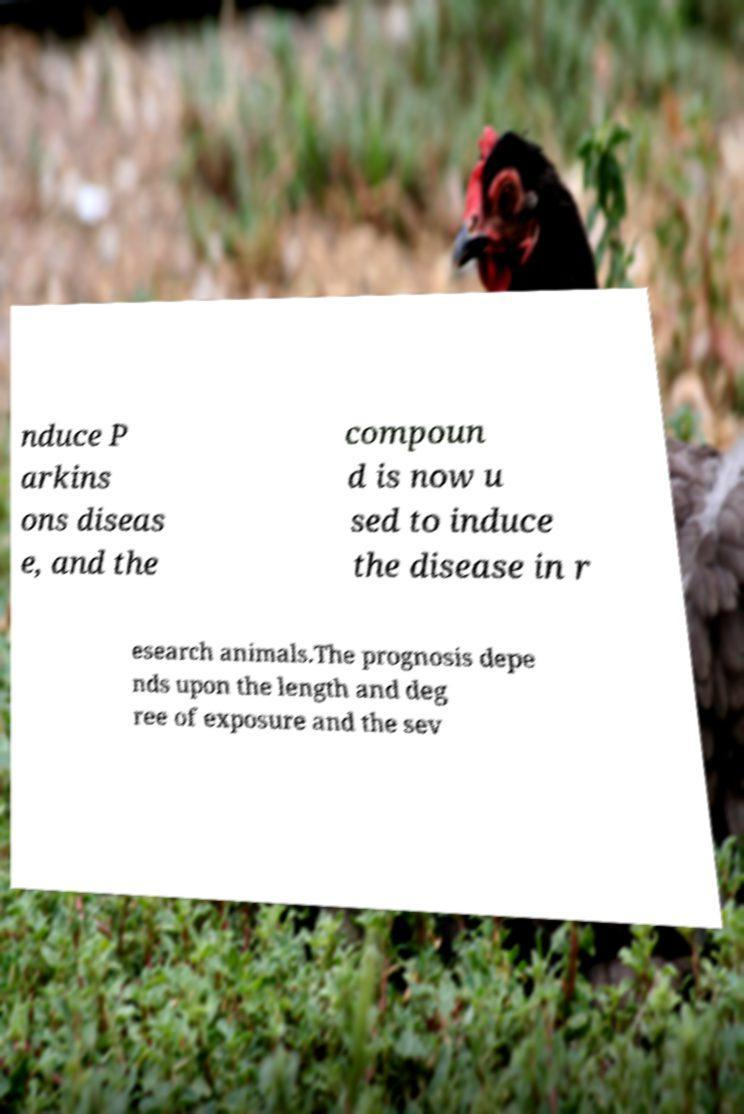Please read and relay the text visible in this image. What does it say? nduce P arkins ons diseas e, and the compoun d is now u sed to induce the disease in r esearch animals.The prognosis depe nds upon the length and deg ree of exposure and the sev 